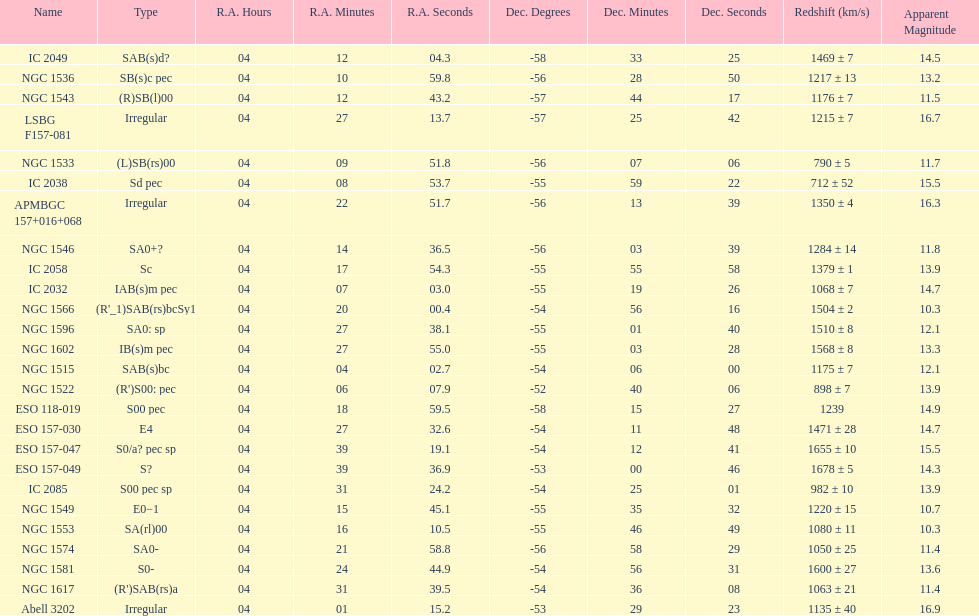Name the member with the highest apparent magnitude. Abell 3202. 